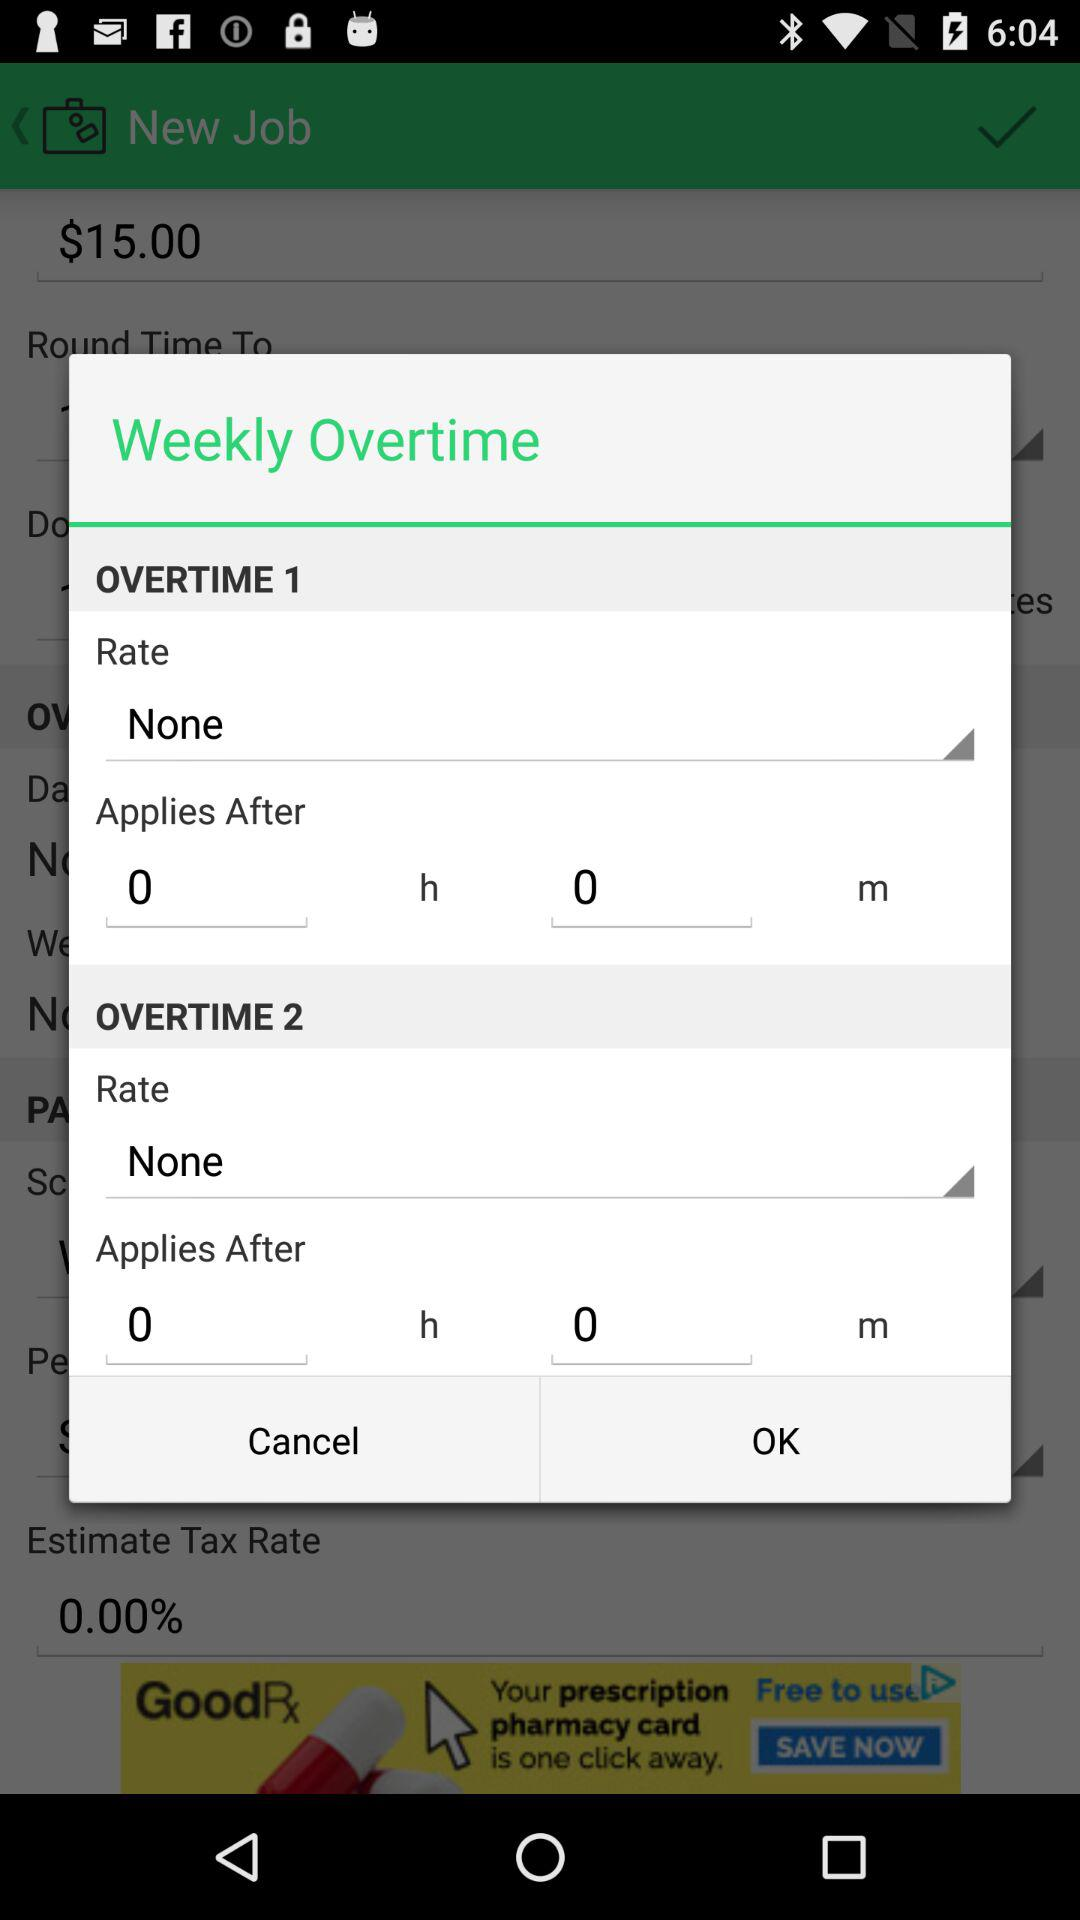How many hours do you have to work before overtime applies for Overtime 1?
Answer the question using a single word or phrase. 0 